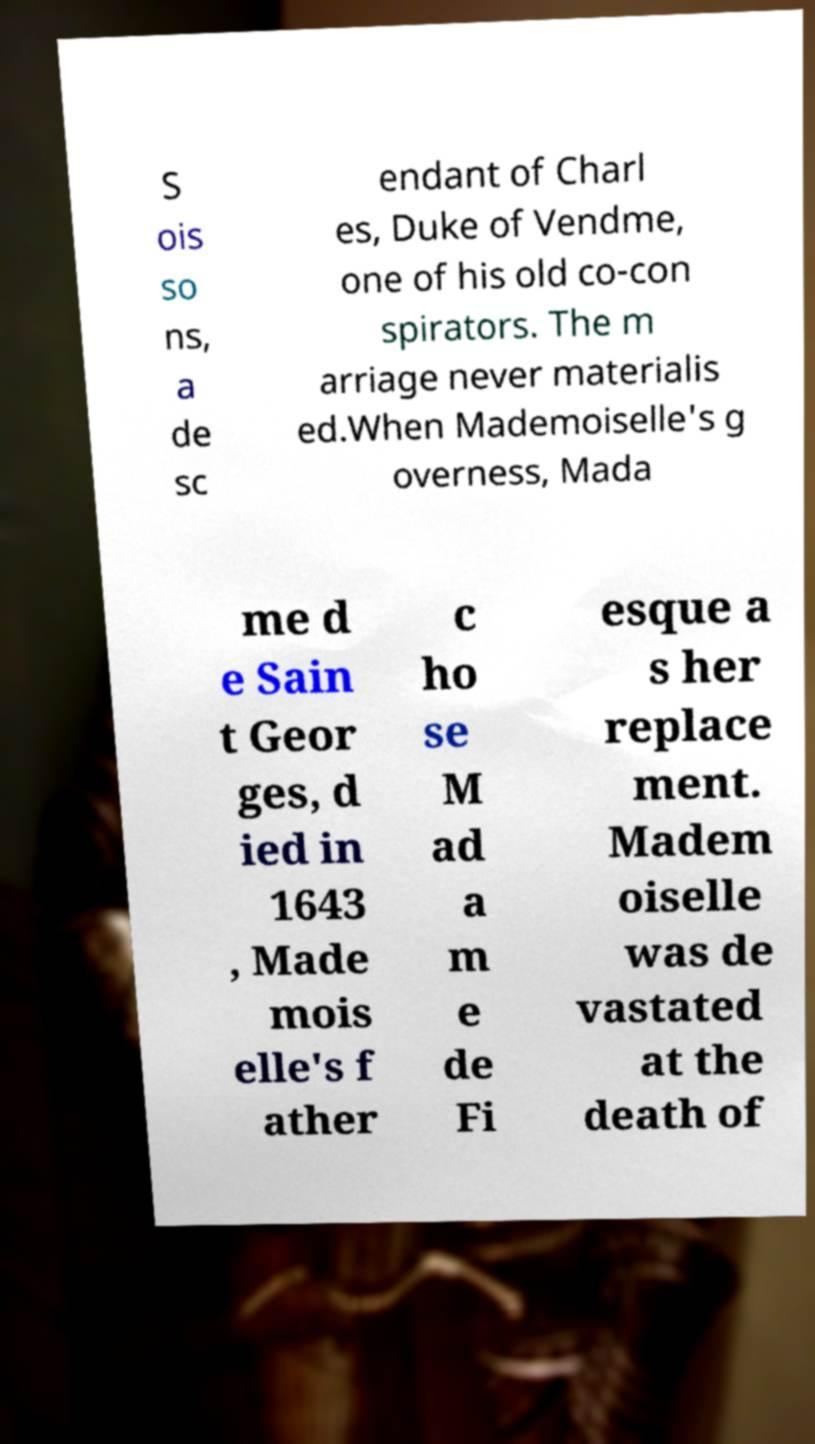Please identify and transcribe the text found in this image. S ois so ns, a de sc endant of Charl es, Duke of Vendme, one of his old co-con spirators. The m arriage never materialis ed.When Mademoiselle's g overness, Mada me d e Sain t Geor ges, d ied in 1643 , Made mois elle's f ather c ho se M ad a m e de Fi esque a s her replace ment. Madem oiselle was de vastated at the death of 